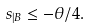<formula> <loc_0><loc_0><loc_500><loc_500>s _ { | B } \leq - \theta / 4 .</formula> 